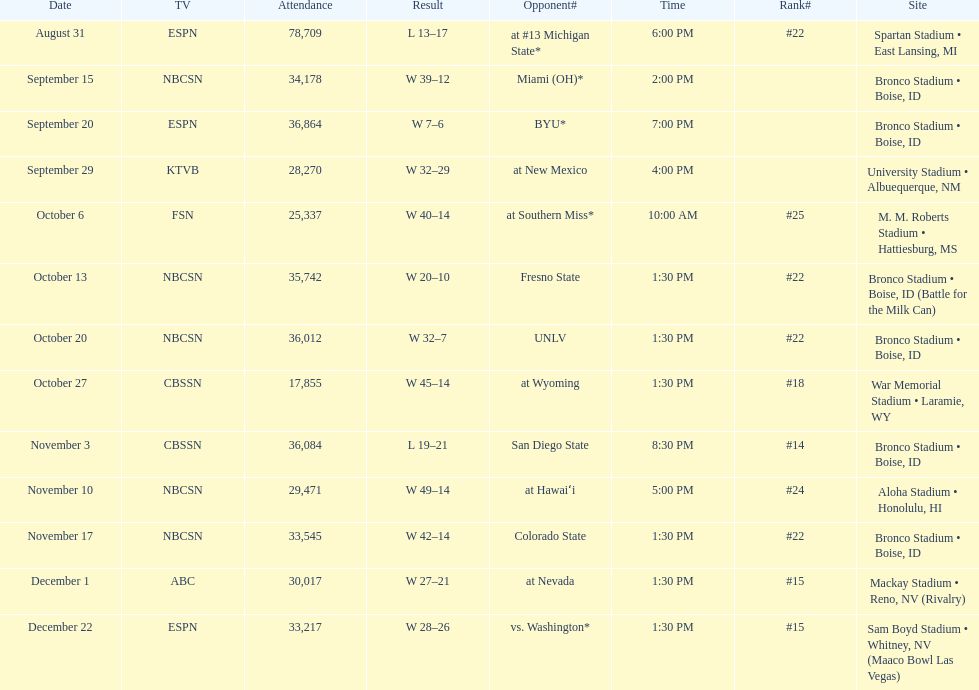Opponent broncos faced next after unlv Wyoming. 